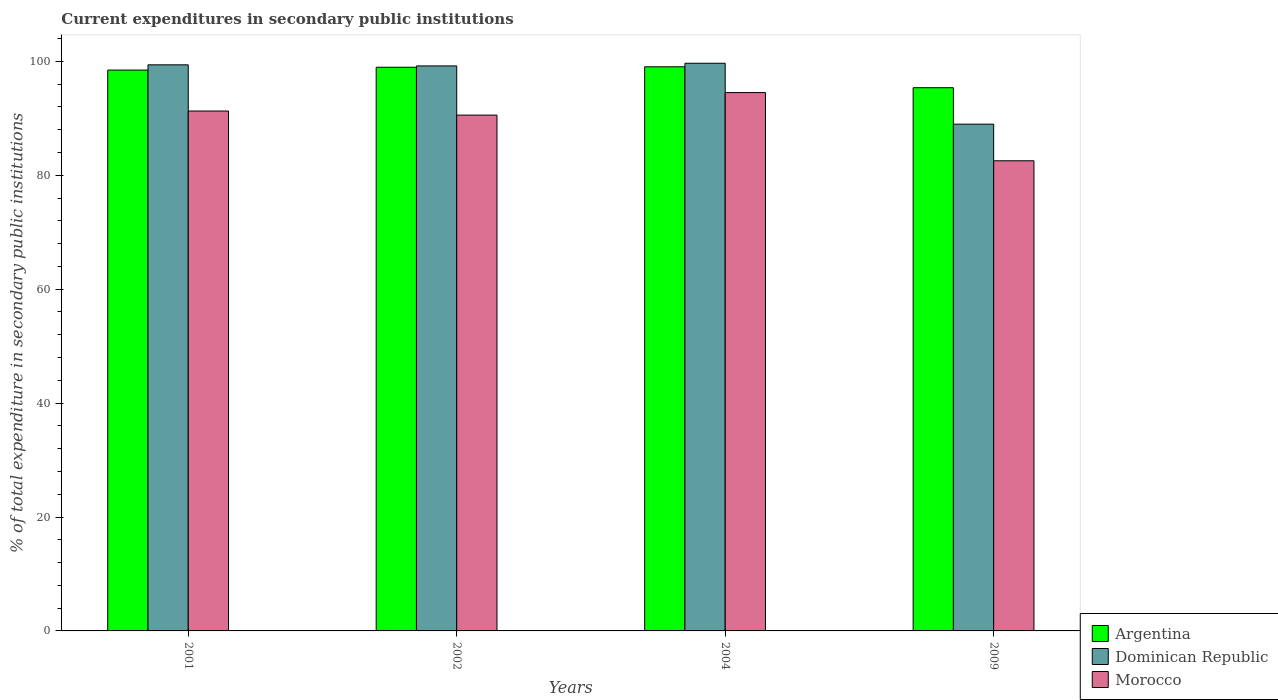How many different coloured bars are there?
Give a very brief answer. 3. How many groups of bars are there?
Provide a succinct answer. 4. Are the number of bars per tick equal to the number of legend labels?
Your answer should be very brief. Yes. Are the number of bars on each tick of the X-axis equal?
Your answer should be very brief. Yes. How many bars are there on the 1st tick from the right?
Offer a very short reply. 3. What is the label of the 4th group of bars from the left?
Make the answer very short. 2009. In how many cases, is the number of bars for a given year not equal to the number of legend labels?
Provide a succinct answer. 0. What is the current expenditures in secondary public institutions in Argentina in 2002?
Your answer should be very brief. 98.98. Across all years, what is the maximum current expenditures in secondary public institutions in Morocco?
Ensure brevity in your answer.  94.53. Across all years, what is the minimum current expenditures in secondary public institutions in Argentina?
Provide a succinct answer. 95.38. In which year was the current expenditures in secondary public institutions in Morocco maximum?
Provide a succinct answer. 2004. In which year was the current expenditures in secondary public institutions in Argentina minimum?
Keep it short and to the point. 2009. What is the total current expenditures in secondary public institutions in Morocco in the graph?
Provide a succinct answer. 358.94. What is the difference between the current expenditures in secondary public institutions in Argentina in 2002 and that in 2004?
Provide a short and direct response. -0.08. What is the difference between the current expenditures in secondary public institutions in Dominican Republic in 2009 and the current expenditures in secondary public institutions in Argentina in 2004?
Provide a succinct answer. -10.07. What is the average current expenditures in secondary public institutions in Morocco per year?
Your response must be concise. 89.74. In the year 2009, what is the difference between the current expenditures in secondary public institutions in Dominican Republic and current expenditures in secondary public institutions in Argentina?
Your response must be concise. -6.4. In how many years, is the current expenditures in secondary public institutions in Morocco greater than 96 %?
Make the answer very short. 0. What is the ratio of the current expenditures in secondary public institutions in Morocco in 2002 to that in 2004?
Make the answer very short. 0.96. What is the difference between the highest and the second highest current expenditures in secondary public institutions in Dominican Republic?
Offer a terse response. 0.27. What is the difference between the highest and the lowest current expenditures in secondary public institutions in Morocco?
Make the answer very short. 11.97. In how many years, is the current expenditures in secondary public institutions in Argentina greater than the average current expenditures in secondary public institutions in Argentina taken over all years?
Your answer should be compact. 3. Is the sum of the current expenditures in secondary public institutions in Morocco in 2002 and 2009 greater than the maximum current expenditures in secondary public institutions in Dominican Republic across all years?
Provide a short and direct response. Yes. Are all the bars in the graph horizontal?
Keep it short and to the point. No. What is the difference between two consecutive major ticks on the Y-axis?
Your answer should be very brief. 20. Are the values on the major ticks of Y-axis written in scientific E-notation?
Make the answer very short. No. Does the graph contain grids?
Offer a terse response. No. How many legend labels are there?
Keep it short and to the point. 3. What is the title of the graph?
Offer a terse response. Current expenditures in secondary public institutions. Does "Mauritius" appear as one of the legend labels in the graph?
Your answer should be compact. No. What is the label or title of the Y-axis?
Provide a short and direct response. % of total expenditure in secondary public institutions. What is the % of total expenditure in secondary public institutions in Argentina in 2001?
Keep it short and to the point. 98.48. What is the % of total expenditure in secondary public institutions of Dominican Republic in 2001?
Offer a very short reply. 99.4. What is the % of total expenditure in secondary public institutions of Morocco in 2001?
Provide a succinct answer. 91.29. What is the % of total expenditure in secondary public institutions in Argentina in 2002?
Offer a very short reply. 98.98. What is the % of total expenditure in secondary public institutions in Dominican Republic in 2002?
Give a very brief answer. 99.21. What is the % of total expenditure in secondary public institutions in Morocco in 2002?
Provide a short and direct response. 90.57. What is the % of total expenditure in secondary public institutions of Argentina in 2004?
Your response must be concise. 99.06. What is the % of total expenditure in secondary public institutions in Dominican Republic in 2004?
Provide a short and direct response. 99.68. What is the % of total expenditure in secondary public institutions in Morocco in 2004?
Keep it short and to the point. 94.53. What is the % of total expenditure in secondary public institutions in Argentina in 2009?
Your response must be concise. 95.38. What is the % of total expenditure in secondary public institutions in Dominican Republic in 2009?
Ensure brevity in your answer.  88.98. What is the % of total expenditure in secondary public institutions of Morocco in 2009?
Your response must be concise. 82.55. Across all years, what is the maximum % of total expenditure in secondary public institutions in Argentina?
Make the answer very short. 99.06. Across all years, what is the maximum % of total expenditure in secondary public institutions of Dominican Republic?
Your answer should be very brief. 99.68. Across all years, what is the maximum % of total expenditure in secondary public institutions of Morocco?
Offer a terse response. 94.53. Across all years, what is the minimum % of total expenditure in secondary public institutions of Argentina?
Ensure brevity in your answer.  95.38. Across all years, what is the minimum % of total expenditure in secondary public institutions of Dominican Republic?
Your answer should be compact. 88.98. Across all years, what is the minimum % of total expenditure in secondary public institutions of Morocco?
Give a very brief answer. 82.55. What is the total % of total expenditure in secondary public institutions of Argentina in the graph?
Make the answer very short. 391.9. What is the total % of total expenditure in secondary public institutions of Dominican Republic in the graph?
Ensure brevity in your answer.  387.27. What is the total % of total expenditure in secondary public institutions in Morocco in the graph?
Offer a very short reply. 358.94. What is the difference between the % of total expenditure in secondary public institutions of Argentina in 2001 and that in 2002?
Ensure brevity in your answer.  -0.5. What is the difference between the % of total expenditure in secondary public institutions in Dominican Republic in 2001 and that in 2002?
Ensure brevity in your answer.  0.19. What is the difference between the % of total expenditure in secondary public institutions in Morocco in 2001 and that in 2002?
Provide a short and direct response. 0.72. What is the difference between the % of total expenditure in secondary public institutions of Argentina in 2001 and that in 2004?
Your answer should be compact. -0.58. What is the difference between the % of total expenditure in secondary public institutions of Dominican Republic in 2001 and that in 2004?
Give a very brief answer. -0.27. What is the difference between the % of total expenditure in secondary public institutions in Morocco in 2001 and that in 2004?
Provide a succinct answer. -3.24. What is the difference between the % of total expenditure in secondary public institutions of Argentina in 2001 and that in 2009?
Your answer should be very brief. 3.1. What is the difference between the % of total expenditure in secondary public institutions in Dominican Republic in 2001 and that in 2009?
Make the answer very short. 10.42. What is the difference between the % of total expenditure in secondary public institutions of Morocco in 2001 and that in 2009?
Ensure brevity in your answer.  8.74. What is the difference between the % of total expenditure in secondary public institutions in Argentina in 2002 and that in 2004?
Ensure brevity in your answer.  -0.08. What is the difference between the % of total expenditure in secondary public institutions of Dominican Republic in 2002 and that in 2004?
Offer a terse response. -0.47. What is the difference between the % of total expenditure in secondary public institutions of Morocco in 2002 and that in 2004?
Provide a short and direct response. -3.95. What is the difference between the % of total expenditure in secondary public institutions of Argentina in 2002 and that in 2009?
Make the answer very short. 3.6. What is the difference between the % of total expenditure in secondary public institutions of Dominican Republic in 2002 and that in 2009?
Ensure brevity in your answer.  10.23. What is the difference between the % of total expenditure in secondary public institutions in Morocco in 2002 and that in 2009?
Your answer should be compact. 8.02. What is the difference between the % of total expenditure in secondary public institutions of Argentina in 2004 and that in 2009?
Make the answer very short. 3.67. What is the difference between the % of total expenditure in secondary public institutions in Dominican Republic in 2004 and that in 2009?
Give a very brief answer. 10.69. What is the difference between the % of total expenditure in secondary public institutions in Morocco in 2004 and that in 2009?
Ensure brevity in your answer.  11.97. What is the difference between the % of total expenditure in secondary public institutions of Argentina in 2001 and the % of total expenditure in secondary public institutions of Dominican Republic in 2002?
Give a very brief answer. -0.73. What is the difference between the % of total expenditure in secondary public institutions in Argentina in 2001 and the % of total expenditure in secondary public institutions in Morocco in 2002?
Offer a very short reply. 7.91. What is the difference between the % of total expenditure in secondary public institutions of Dominican Republic in 2001 and the % of total expenditure in secondary public institutions of Morocco in 2002?
Ensure brevity in your answer.  8.83. What is the difference between the % of total expenditure in secondary public institutions of Argentina in 2001 and the % of total expenditure in secondary public institutions of Dominican Republic in 2004?
Your answer should be very brief. -1.2. What is the difference between the % of total expenditure in secondary public institutions in Argentina in 2001 and the % of total expenditure in secondary public institutions in Morocco in 2004?
Your answer should be very brief. 3.95. What is the difference between the % of total expenditure in secondary public institutions of Dominican Republic in 2001 and the % of total expenditure in secondary public institutions of Morocco in 2004?
Make the answer very short. 4.88. What is the difference between the % of total expenditure in secondary public institutions of Argentina in 2001 and the % of total expenditure in secondary public institutions of Dominican Republic in 2009?
Make the answer very short. 9.5. What is the difference between the % of total expenditure in secondary public institutions in Argentina in 2001 and the % of total expenditure in secondary public institutions in Morocco in 2009?
Make the answer very short. 15.93. What is the difference between the % of total expenditure in secondary public institutions of Dominican Republic in 2001 and the % of total expenditure in secondary public institutions of Morocco in 2009?
Your response must be concise. 16.85. What is the difference between the % of total expenditure in secondary public institutions of Argentina in 2002 and the % of total expenditure in secondary public institutions of Dominican Republic in 2004?
Ensure brevity in your answer.  -0.7. What is the difference between the % of total expenditure in secondary public institutions of Argentina in 2002 and the % of total expenditure in secondary public institutions of Morocco in 2004?
Offer a very short reply. 4.45. What is the difference between the % of total expenditure in secondary public institutions of Dominican Republic in 2002 and the % of total expenditure in secondary public institutions of Morocco in 2004?
Offer a terse response. 4.68. What is the difference between the % of total expenditure in secondary public institutions of Argentina in 2002 and the % of total expenditure in secondary public institutions of Dominican Republic in 2009?
Make the answer very short. 10. What is the difference between the % of total expenditure in secondary public institutions of Argentina in 2002 and the % of total expenditure in secondary public institutions of Morocco in 2009?
Offer a terse response. 16.42. What is the difference between the % of total expenditure in secondary public institutions of Dominican Republic in 2002 and the % of total expenditure in secondary public institutions of Morocco in 2009?
Your response must be concise. 16.66. What is the difference between the % of total expenditure in secondary public institutions in Argentina in 2004 and the % of total expenditure in secondary public institutions in Dominican Republic in 2009?
Provide a succinct answer. 10.07. What is the difference between the % of total expenditure in secondary public institutions in Argentina in 2004 and the % of total expenditure in secondary public institutions in Morocco in 2009?
Your response must be concise. 16.5. What is the difference between the % of total expenditure in secondary public institutions of Dominican Republic in 2004 and the % of total expenditure in secondary public institutions of Morocco in 2009?
Give a very brief answer. 17.12. What is the average % of total expenditure in secondary public institutions of Argentina per year?
Provide a short and direct response. 97.97. What is the average % of total expenditure in secondary public institutions of Dominican Republic per year?
Your answer should be very brief. 96.82. What is the average % of total expenditure in secondary public institutions in Morocco per year?
Ensure brevity in your answer.  89.74. In the year 2001, what is the difference between the % of total expenditure in secondary public institutions of Argentina and % of total expenditure in secondary public institutions of Dominican Republic?
Ensure brevity in your answer.  -0.92. In the year 2001, what is the difference between the % of total expenditure in secondary public institutions in Argentina and % of total expenditure in secondary public institutions in Morocco?
Provide a short and direct response. 7.19. In the year 2001, what is the difference between the % of total expenditure in secondary public institutions in Dominican Republic and % of total expenditure in secondary public institutions in Morocco?
Your response must be concise. 8.11. In the year 2002, what is the difference between the % of total expenditure in secondary public institutions of Argentina and % of total expenditure in secondary public institutions of Dominican Republic?
Ensure brevity in your answer.  -0.23. In the year 2002, what is the difference between the % of total expenditure in secondary public institutions in Argentina and % of total expenditure in secondary public institutions in Morocco?
Provide a short and direct response. 8.4. In the year 2002, what is the difference between the % of total expenditure in secondary public institutions of Dominican Republic and % of total expenditure in secondary public institutions of Morocco?
Offer a very short reply. 8.64. In the year 2004, what is the difference between the % of total expenditure in secondary public institutions of Argentina and % of total expenditure in secondary public institutions of Dominican Republic?
Offer a terse response. -0.62. In the year 2004, what is the difference between the % of total expenditure in secondary public institutions of Argentina and % of total expenditure in secondary public institutions of Morocco?
Your answer should be compact. 4.53. In the year 2004, what is the difference between the % of total expenditure in secondary public institutions in Dominican Republic and % of total expenditure in secondary public institutions in Morocco?
Ensure brevity in your answer.  5.15. In the year 2009, what is the difference between the % of total expenditure in secondary public institutions of Argentina and % of total expenditure in secondary public institutions of Dominican Republic?
Your response must be concise. 6.4. In the year 2009, what is the difference between the % of total expenditure in secondary public institutions in Argentina and % of total expenditure in secondary public institutions in Morocco?
Your answer should be very brief. 12.83. In the year 2009, what is the difference between the % of total expenditure in secondary public institutions in Dominican Republic and % of total expenditure in secondary public institutions in Morocco?
Your answer should be very brief. 6.43. What is the ratio of the % of total expenditure in secondary public institutions in Morocco in 2001 to that in 2002?
Your response must be concise. 1.01. What is the ratio of the % of total expenditure in secondary public institutions of Argentina in 2001 to that in 2004?
Make the answer very short. 0.99. What is the ratio of the % of total expenditure in secondary public institutions in Dominican Republic in 2001 to that in 2004?
Provide a succinct answer. 1. What is the ratio of the % of total expenditure in secondary public institutions of Morocco in 2001 to that in 2004?
Ensure brevity in your answer.  0.97. What is the ratio of the % of total expenditure in secondary public institutions of Argentina in 2001 to that in 2009?
Offer a terse response. 1.03. What is the ratio of the % of total expenditure in secondary public institutions in Dominican Republic in 2001 to that in 2009?
Your response must be concise. 1.12. What is the ratio of the % of total expenditure in secondary public institutions in Morocco in 2001 to that in 2009?
Ensure brevity in your answer.  1.11. What is the ratio of the % of total expenditure in secondary public institutions of Argentina in 2002 to that in 2004?
Ensure brevity in your answer.  1. What is the ratio of the % of total expenditure in secondary public institutions of Morocco in 2002 to that in 2004?
Your response must be concise. 0.96. What is the ratio of the % of total expenditure in secondary public institutions of Argentina in 2002 to that in 2009?
Make the answer very short. 1.04. What is the ratio of the % of total expenditure in secondary public institutions in Dominican Republic in 2002 to that in 2009?
Offer a very short reply. 1.11. What is the ratio of the % of total expenditure in secondary public institutions in Morocco in 2002 to that in 2009?
Your response must be concise. 1.1. What is the ratio of the % of total expenditure in secondary public institutions of Dominican Republic in 2004 to that in 2009?
Provide a succinct answer. 1.12. What is the ratio of the % of total expenditure in secondary public institutions in Morocco in 2004 to that in 2009?
Ensure brevity in your answer.  1.15. What is the difference between the highest and the second highest % of total expenditure in secondary public institutions in Argentina?
Your answer should be compact. 0.08. What is the difference between the highest and the second highest % of total expenditure in secondary public institutions in Dominican Republic?
Your answer should be compact. 0.27. What is the difference between the highest and the second highest % of total expenditure in secondary public institutions of Morocco?
Your answer should be compact. 3.24. What is the difference between the highest and the lowest % of total expenditure in secondary public institutions in Argentina?
Your answer should be very brief. 3.67. What is the difference between the highest and the lowest % of total expenditure in secondary public institutions of Dominican Republic?
Provide a succinct answer. 10.69. What is the difference between the highest and the lowest % of total expenditure in secondary public institutions in Morocco?
Make the answer very short. 11.97. 